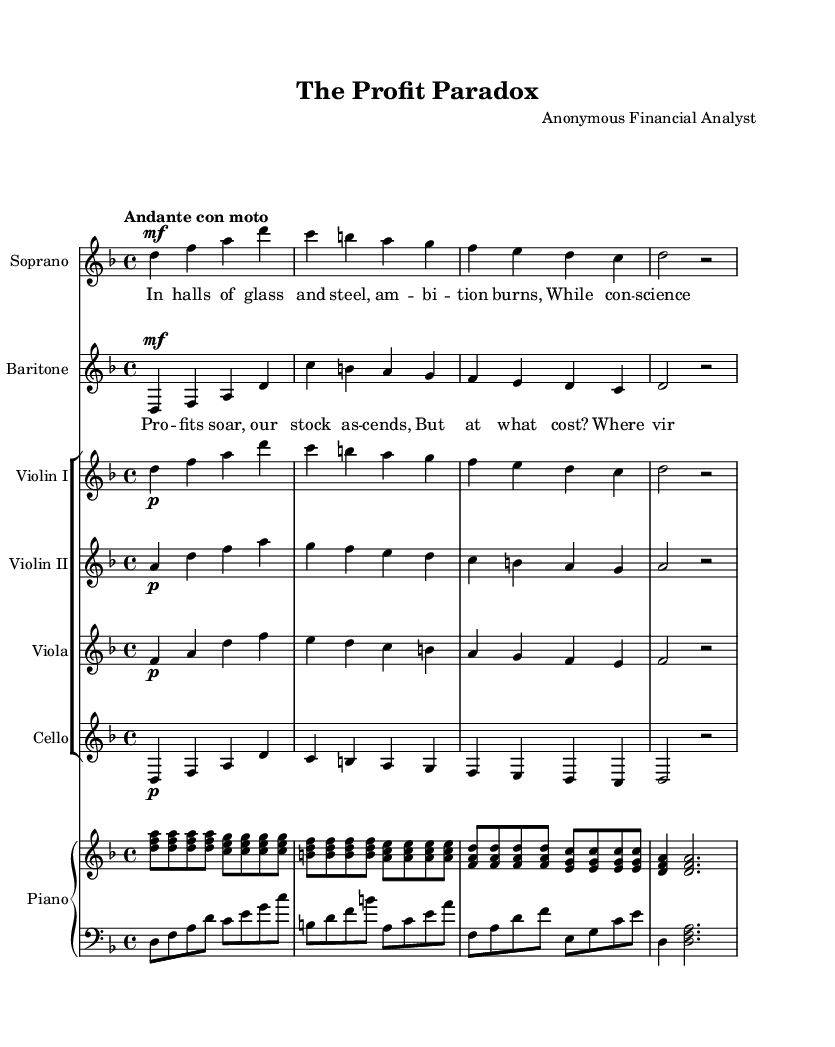What is the key signature of this music? The key signature is indicated in the global settings of the sheet music. Here, it is set to D minor, which consists of one flat (B flat).
Answer: D minor What is the time signature of this music? The time signature is specified in the global settings as well. It shows a 4/4 time signature, indicating four beats per measure with a quarter note receiving one beat.
Answer: 4/4 What is the tempo marking for the piece? The tempo marking is provided in the global settings under tempo, which states "Andante con moto," indicating a moderately slow tempo with a slight movement.
Answer: Andante con moto How many staves are used in the music score? To determine the number of staves, we can count the individual staves listed under the score. There are five staves: one for soprano, one for baritone, and three grouped for strings, plus one piano staff that is divided into RH and LH.
Answer: Five How do the soprano lyrics reflect the opera's theme? The soprano lyrics emphasize individual ambition through the imagery of "halls of glass and steel" and the internal conflict represented by "conscience whispers." This captures the tension between ambition and ethical considerations.
Answer: Ambition vs ethics What instruments are included in the orchestration? By reviewing the score, we can identify the instruments listed. They include Soprano, Baritone, Violin I, Violin II, Viola, Cello, and Piano. The piano part is divided into right-hand and left-hand sections.
Answer: Soprano, Baritone, Violin I, Violin II, Viola, Cello, Piano What is the dynamic marking for the Soprano part? The dynamic marking indicates how loudly or softly the music should be performed. In the soprano part, it is marked as "mf," which stands for "mezzo forte," meaning moderately loud.
Answer: Mezzo forte 